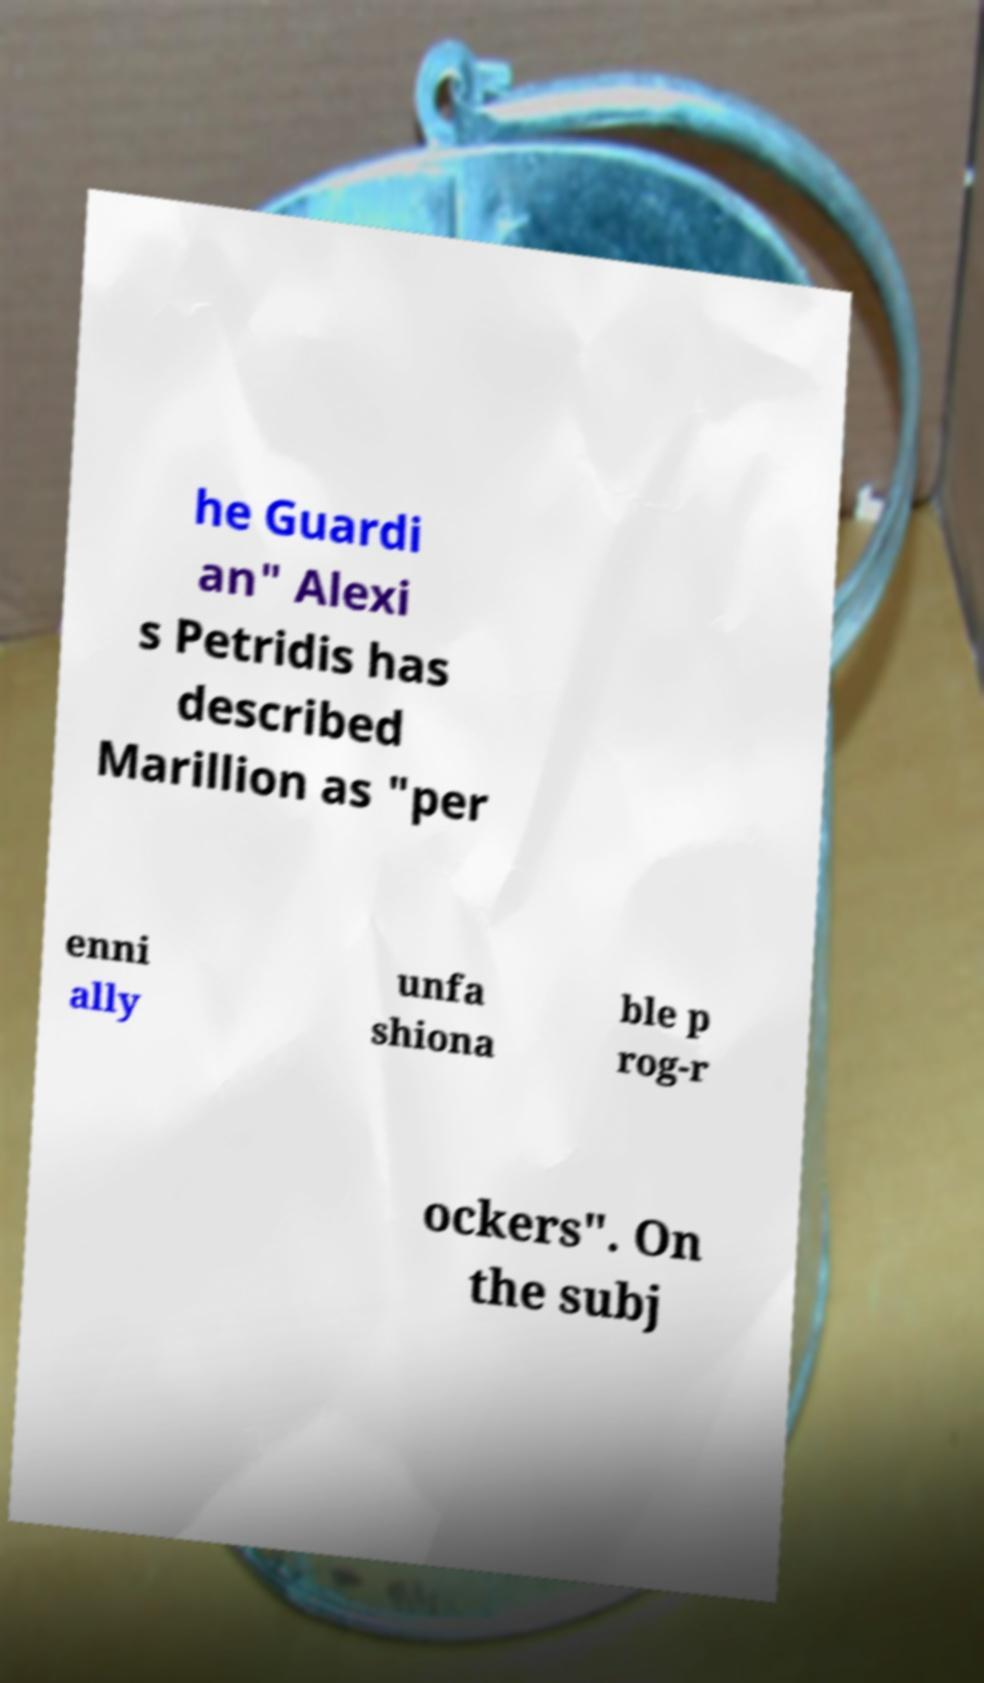Can you read and provide the text displayed in the image?This photo seems to have some interesting text. Can you extract and type it out for me? he Guardi an" Alexi s Petridis has described Marillion as "per enni ally unfa shiona ble p rog-r ockers". On the subj 